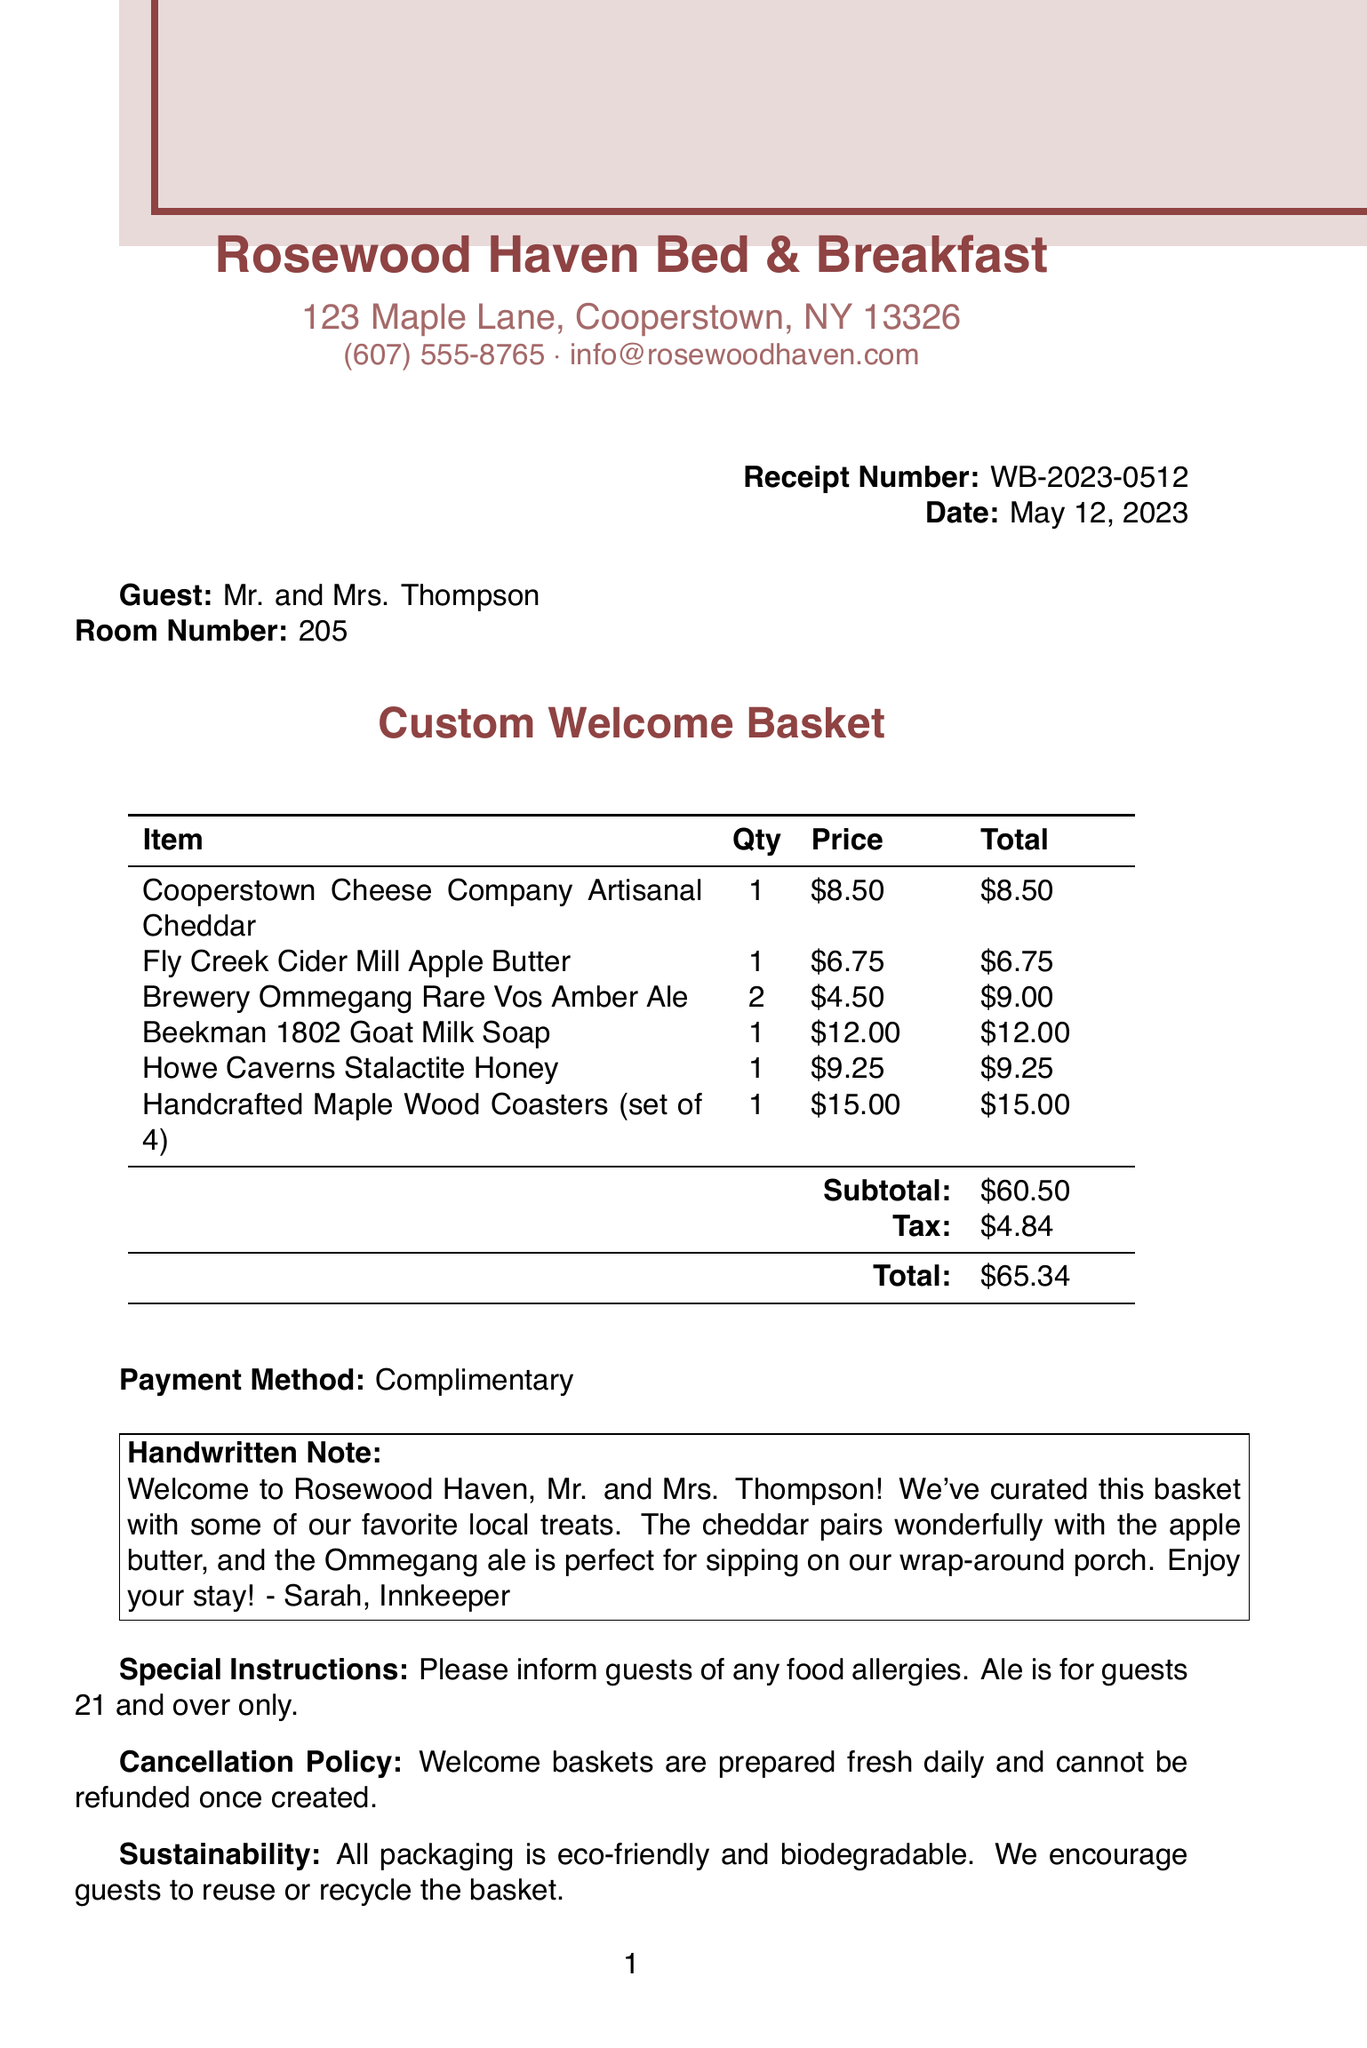What is the business name? The business name is presented at the top of the receipt.
Answer: Rosewood Haven Bed & Breakfast What is the receipt number? The receipt number is located in the top right corner of the document.
Answer: WB-2023-0512 Who is the guest? The guest's name is provided in the document.
Answer: Mr. and Mrs. Thompson What is the total amount charged? The total amount charged is shown at the bottom of the receipt.
Answer: $65.34 What types of items are included in the welcome basket? The items listed in the document are all local products included in the welcome basket.
Answer: Locally sourced products How many Brewery Ommegang Rare Vos Amber Ales were included? The quantity of this specific item in the basket is mentioned.
Answer: 2 What is the sustainability message on the document? The sustainability statement describes the eco-friendly practices associated with the basket.
Answer: All packaging is eco-friendly and biodegradable What is the handwritten note about? The handwritten note welcomes the guests and describes the contents of the basket.
Answer: Welcome to Rosewood Haven, Mr. and Mrs. Thompson! What is the payment method? The payment method is indicated in a section of the document.
Answer: Complimentary What is the cancellation policy for the welcome basket? The cancellation policy outlines the rules regarding refunds for the basket.
Answer: Welcome baskets are prepared fresh daily and cannot be refunded once created 